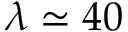<formula> <loc_0><loc_0><loc_500><loc_500>\lambda \simeq 4 0</formula> 